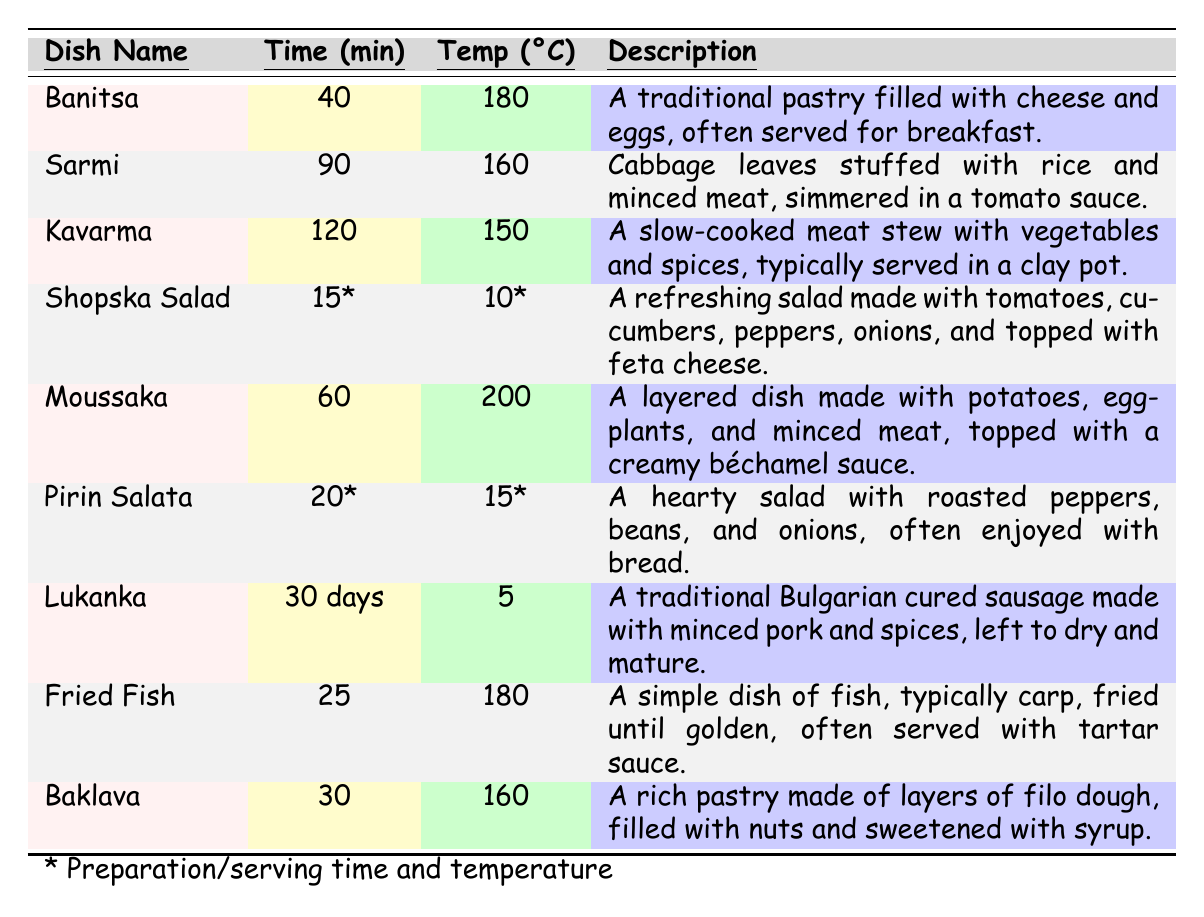What is the cooking time for Banitsa? The table shows that the cooking time for Banitsa is listed as 40 minutes.
Answer: 40 minutes How long does it take to cook Sarmi? According to the table, Sarmi has a cooking time of 90 minutes.
Answer: 90 minutes What is the baking temperature for Moussaka? The table indicates that the baking temperature for Moussaka is 200 degrees Celsius.
Answer: 200 degrees Celsius Which dish requires the longest cooking time? By comparing the cooking times in the table, Kavarma requires the longest cooking time of 120 minutes.
Answer: Kavarma Is Shopska Salad served at a cold temperature? Yes, the table notes that Shopska Salad is served at a temperature of 10 degrees Celsius, which is cold.
Answer: Yes How many dishes have a baking temperature of 160 degrees Celsius? The table shows two dishes, Sarmi and Baklava, that have a baking temperature of 160 degrees Celsius.
Answer: 2 dishes What is the average cooking time of all dishes listed? The cooking times to consider are 40 (Banitsa), 90 (Sarmi), 120 (Kavarma), 60 (Moussaka), 25 (Fried Fish). Adding these gives 335 minutes. There are 5 dishes, so the average cooking time is 335 / 5 = 67 minutes.
Answer: 67 minutes Which dish has the lowest serving temperature and what is it? The table indicates that Pirin Salata is served at 15 degrees Celsius, which is the lowest serving temperature among the salads.
Answer: Pirin Salata If frying fish takes 25 minutes, how long does it take to cook it compared to making Moussaka? The cooking time for Moussaka is 60 minutes and for Fried Fish, it is 25 minutes. The difference in time is 60 - 25 = 35 minutes. Thus, Moussaka takes 35 minutes longer to cook than Fried Fish.
Answer: 35 minutes longer Are there more dishes with a cooking temperature over 180 degrees Celsius or under? The table shows Moussaka (200°C) is the sole dish above 180°C, while Banitsa (180°C), Sarmi (160°C), and Baklava (160°C) are below. Thus, there are 3 dishes under and 1 over, indicating there are more dishes with lower temperatures.
Answer: More under 180 degrees Celsius What is the total preparation time for Baklava and Pirin Salata? The preparation time for Baklava is 30 minutes, and for Pirin Salata is 20 minutes. Adding these gives 30 + 20 = 50 minutes total preparation time.
Answer: 50 minutes 